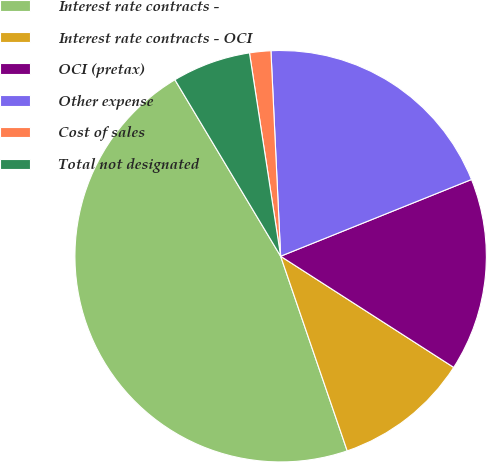Convert chart. <chart><loc_0><loc_0><loc_500><loc_500><pie_chart><fcel>Interest rate contracts -<fcel>Interest rate contracts - OCI<fcel>OCI (pretax)<fcel>Other expense<fcel>Cost of sales<fcel>Total not designated<nl><fcel>46.66%<fcel>10.67%<fcel>15.17%<fcel>19.67%<fcel>1.67%<fcel>6.17%<nl></chart> 